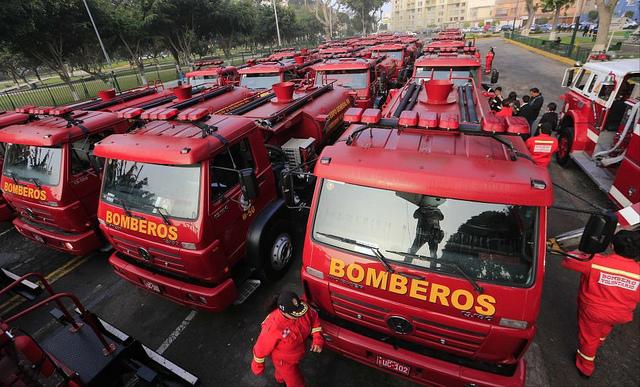What is the brand of this truck?
Keep it brief. Bomberos. Are all the trucks the same?
Give a very brief answer. Yes. What country was this photograph taken?
Keep it brief. Mexico. What color are the fire trucks?
Keep it brief. Red. Is he wearing a blue shirt?
Keep it brief. No. Are the fire trucks all the same model?
Answer briefly. Yes. What company is displayed?
Write a very short answer. Bomberos. 